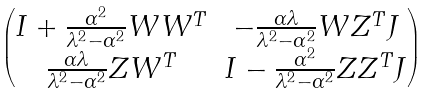Convert formula to latex. <formula><loc_0><loc_0><loc_500><loc_500>\begin{pmatrix} I + \frac { \alpha ^ { 2 } } { \lambda ^ { 2 } - \alpha ^ { 2 } } W W ^ { T } & - \frac { \alpha \lambda } { \lambda ^ { 2 } - \alpha ^ { 2 } } W Z ^ { T } J \\ \frac { \alpha \lambda } { \lambda ^ { 2 } - \alpha ^ { 2 } } Z W ^ { T } & I - \frac { \alpha ^ { 2 } } { \lambda ^ { 2 } - \alpha ^ { 2 } } Z Z ^ { T } J \end{pmatrix}</formula> 